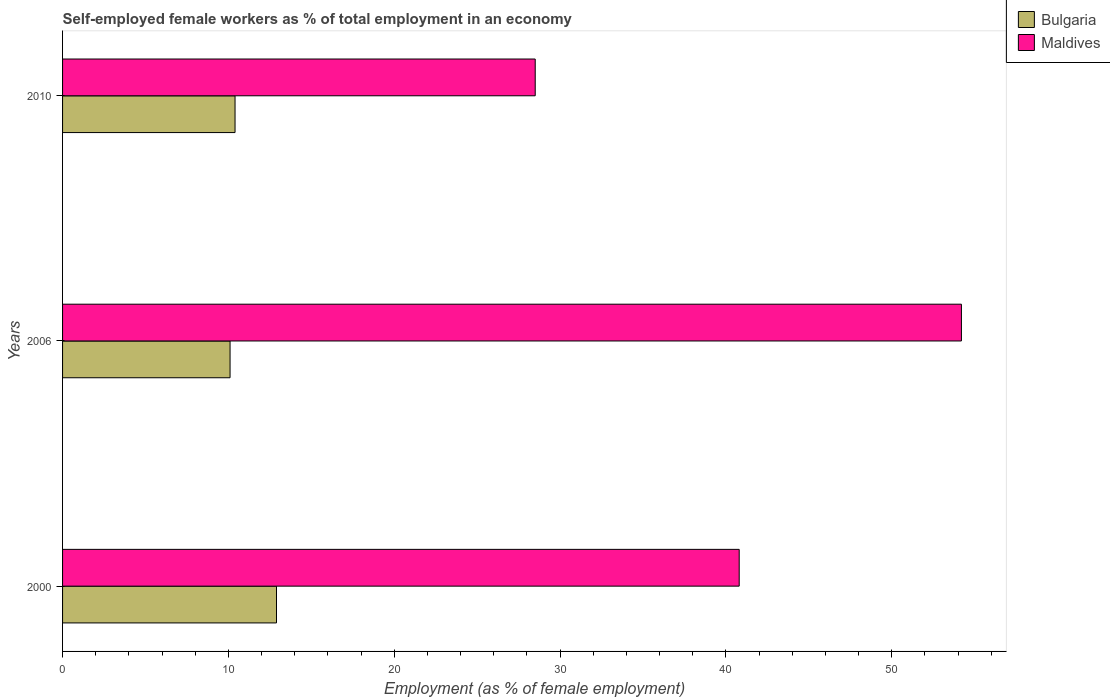How many groups of bars are there?
Your response must be concise. 3. Are the number of bars on each tick of the Y-axis equal?
Provide a short and direct response. Yes. How many bars are there on the 3rd tick from the top?
Your answer should be compact. 2. Across all years, what is the maximum percentage of self-employed female workers in Maldives?
Provide a short and direct response. 54.2. Across all years, what is the minimum percentage of self-employed female workers in Bulgaria?
Provide a short and direct response. 10.1. In which year was the percentage of self-employed female workers in Bulgaria maximum?
Your answer should be very brief. 2000. In which year was the percentage of self-employed female workers in Bulgaria minimum?
Keep it short and to the point. 2006. What is the total percentage of self-employed female workers in Bulgaria in the graph?
Provide a short and direct response. 33.4. What is the difference between the percentage of self-employed female workers in Bulgaria in 2000 and that in 2010?
Provide a short and direct response. 2.5. What is the difference between the percentage of self-employed female workers in Bulgaria in 2006 and the percentage of self-employed female workers in Maldives in 2010?
Your answer should be very brief. -18.4. What is the average percentage of self-employed female workers in Bulgaria per year?
Offer a terse response. 11.13. In the year 2006, what is the difference between the percentage of self-employed female workers in Maldives and percentage of self-employed female workers in Bulgaria?
Your answer should be very brief. 44.1. In how many years, is the percentage of self-employed female workers in Bulgaria greater than 12 %?
Your answer should be compact. 1. What is the ratio of the percentage of self-employed female workers in Bulgaria in 2000 to that in 2010?
Ensure brevity in your answer.  1.24. What is the difference between the highest and the second highest percentage of self-employed female workers in Bulgaria?
Your answer should be compact. 2.5. What is the difference between the highest and the lowest percentage of self-employed female workers in Maldives?
Your answer should be very brief. 25.7. Is the sum of the percentage of self-employed female workers in Maldives in 2000 and 2010 greater than the maximum percentage of self-employed female workers in Bulgaria across all years?
Offer a very short reply. Yes. What does the 1st bar from the top in 2006 represents?
Keep it short and to the point. Maldives. What does the 2nd bar from the bottom in 2006 represents?
Offer a terse response. Maldives. What is the difference between two consecutive major ticks on the X-axis?
Provide a succinct answer. 10. Are the values on the major ticks of X-axis written in scientific E-notation?
Offer a very short reply. No. Does the graph contain grids?
Provide a short and direct response. No. What is the title of the graph?
Give a very brief answer. Self-employed female workers as % of total employment in an economy. What is the label or title of the X-axis?
Offer a very short reply. Employment (as % of female employment). What is the Employment (as % of female employment) in Bulgaria in 2000?
Offer a very short reply. 12.9. What is the Employment (as % of female employment) of Maldives in 2000?
Your response must be concise. 40.8. What is the Employment (as % of female employment) in Bulgaria in 2006?
Give a very brief answer. 10.1. What is the Employment (as % of female employment) in Maldives in 2006?
Keep it short and to the point. 54.2. What is the Employment (as % of female employment) in Bulgaria in 2010?
Keep it short and to the point. 10.4. Across all years, what is the maximum Employment (as % of female employment) in Bulgaria?
Make the answer very short. 12.9. Across all years, what is the maximum Employment (as % of female employment) of Maldives?
Make the answer very short. 54.2. Across all years, what is the minimum Employment (as % of female employment) of Bulgaria?
Provide a succinct answer. 10.1. What is the total Employment (as % of female employment) of Bulgaria in the graph?
Offer a very short reply. 33.4. What is the total Employment (as % of female employment) of Maldives in the graph?
Provide a short and direct response. 123.5. What is the difference between the Employment (as % of female employment) in Bulgaria in 2000 and that in 2010?
Your response must be concise. 2.5. What is the difference between the Employment (as % of female employment) in Bulgaria in 2006 and that in 2010?
Provide a succinct answer. -0.3. What is the difference between the Employment (as % of female employment) in Maldives in 2006 and that in 2010?
Provide a short and direct response. 25.7. What is the difference between the Employment (as % of female employment) of Bulgaria in 2000 and the Employment (as % of female employment) of Maldives in 2006?
Provide a succinct answer. -41.3. What is the difference between the Employment (as % of female employment) of Bulgaria in 2000 and the Employment (as % of female employment) of Maldives in 2010?
Ensure brevity in your answer.  -15.6. What is the difference between the Employment (as % of female employment) in Bulgaria in 2006 and the Employment (as % of female employment) in Maldives in 2010?
Your answer should be compact. -18.4. What is the average Employment (as % of female employment) of Bulgaria per year?
Make the answer very short. 11.13. What is the average Employment (as % of female employment) in Maldives per year?
Provide a short and direct response. 41.17. In the year 2000, what is the difference between the Employment (as % of female employment) in Bulgaria and Employment (as % of female employment) in Maldives?
Your answer should be very brief. -27.9. In the year 2006, what is the difference between the Employment (as % of female employment) in Bulgaria and Employment (as % of female employment) in Maldives?
Your answer should be compact. -44.1. In the year 2010, what is the difference between the Employment (as % of female employment) in Bulgaria and Employment (as % of female employment) in Maldives?
Keep it short and to the point. -18.1. What is the ratio of the Employment (as % of female employment) of Bulgaria in 2000 to that in 2006?
Provide a short and direct response. 1.28. What is the ratio of the Employment (as % of female employment) in Maldives in 2000 to that in 2006?
Your answer should be very brief. 0.75. What is the ratio of the Employment (as % of female employment) of Bulgaria in 2000 to that in 2010?
Provide a succinct answer. 1.24. What is the ratio of the Employment (as % of female employment) in Maldives in 2000 to that in 2010?
Provide a short and direct response. 1.43. What is the ratio of the Employment (as % of female employment) in Bulgaria in 2006 to that in 2010?
Give a very brief answer. 0.97. What is the ratio of the Employment (as % of female employment) of Maldives in 2006 to that in 2010?
Ensure brevity in your answer.  1.9. What is the difference between the highest and the second highest Employment (as % of female employment) in Bulgaria?
Ensure brevity in your answer.  2.5. What is the difference between the highest and the second highest Employment (as % of female employment) in Maldives?
Give a very brief answer. 13.4. What is the difference between the highest and the lowest Employment (as % of female employment) of Maldives?
Give a very brief answer. 25.7. 